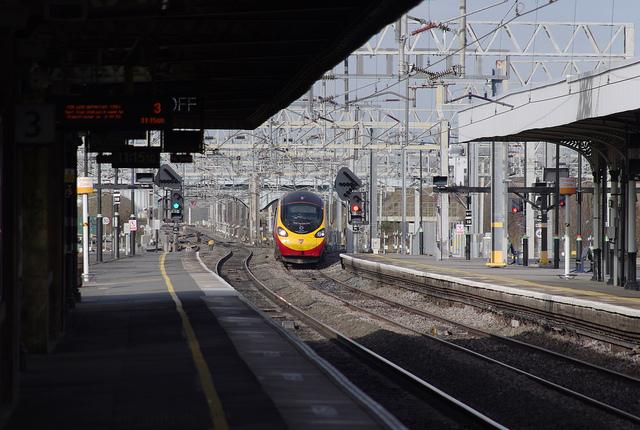Are people waiting for the train?
Answer briefly. No. Is the weather bad?
Answer briefly. No. How many tracks are seen?
Keep it brief. 2. How many trains are seen?
Quick response, please. 1. 